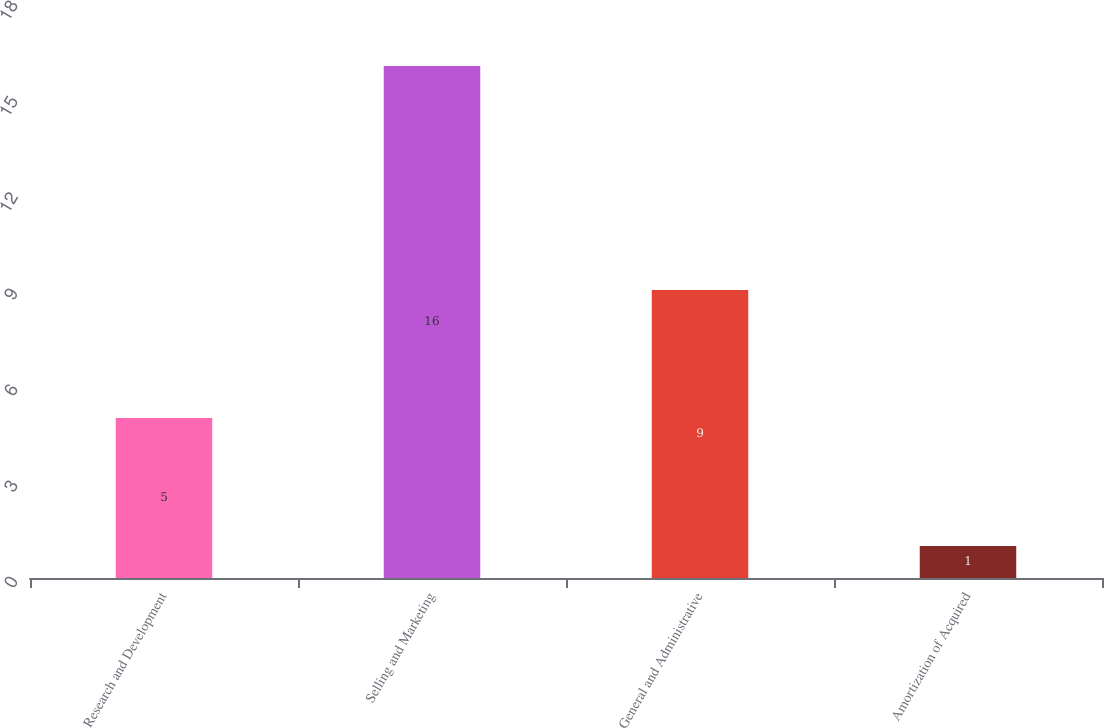Convert chart to OTSL. <chart><loc_0><loc_0><loc_500><loc_500><bar_chart><fcel>Research and Development<fcel>Selling and Marketing<fcel>General and Administrative<fcel>Amortization of Acquired<nl><fcel>5<fcel>16<fcel>9<fcel>1<nl></chart> 